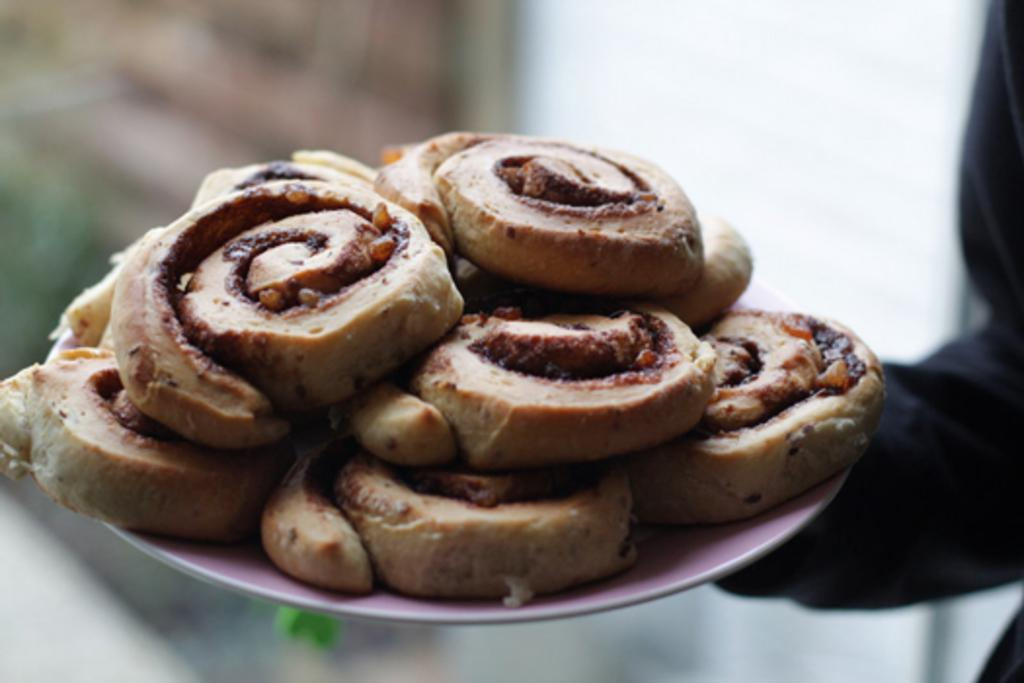What type of objects can be seen in the image? There are food items in the image. What color are the food items? The food items are in brown color. Can you describe the background of the image? The background of the image is blurred. How many children are playing on the bridge in the image? There is no bridge or children present in the image. 